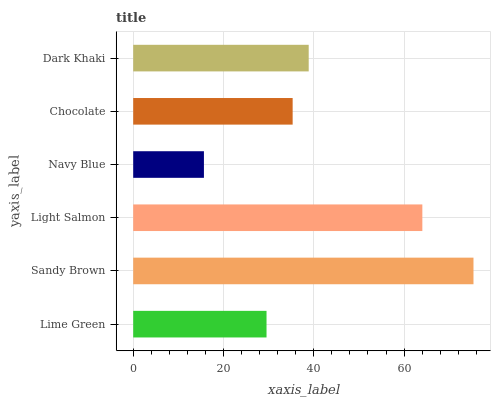Is Navy Blue the minimum?
Answer yes or no. Yes. Is Sandy Brown the maximum?
Answer yes or no. Yes. Is Light Salmon the minimum?
Answer yes or no. No. Is Light Salmon the maximum?
Answer yes or no. No. Is Sandy Brown greater than Light Salmon?
Answer yes or no. Yes. Is Light Salmon less than Sandy Brown?
Answer yes or no. Yes. Is Light Salmon greater than Sandy Brown?
Answer yes or no. No. Is Sandy Brown less than Light Salmon?
Answer yes or no. No. Is Dark Khaki the high median?
Answer yes or no. Yes. Is Chocolate the low median?
Answer yes or no. Yes. Is Navy Blue the high median?
Answer yes or no. No. Is Light Salmon the low median?
Answer yes or no. No. 